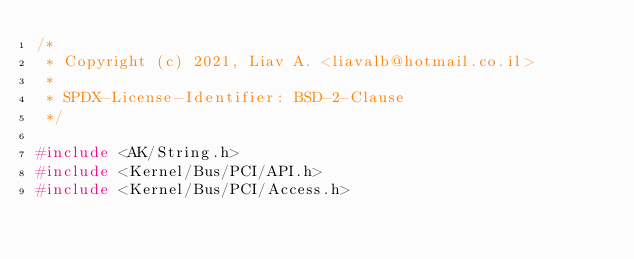Convert code to text. <code><loc_0><loc_0><loc_500><loc_500><_C++_>/*
 * Copyright (c) 2021, Liav A. <liavalb@hotmail.co.il>
 *
 * SPDX-License-Identifier: BSD-2-Clause
 */

#include <AK/String.h>
#include <Kernel/Bus/PCI/API.h>
#include <Kernel/Bus/PCI/Access.h></code> 